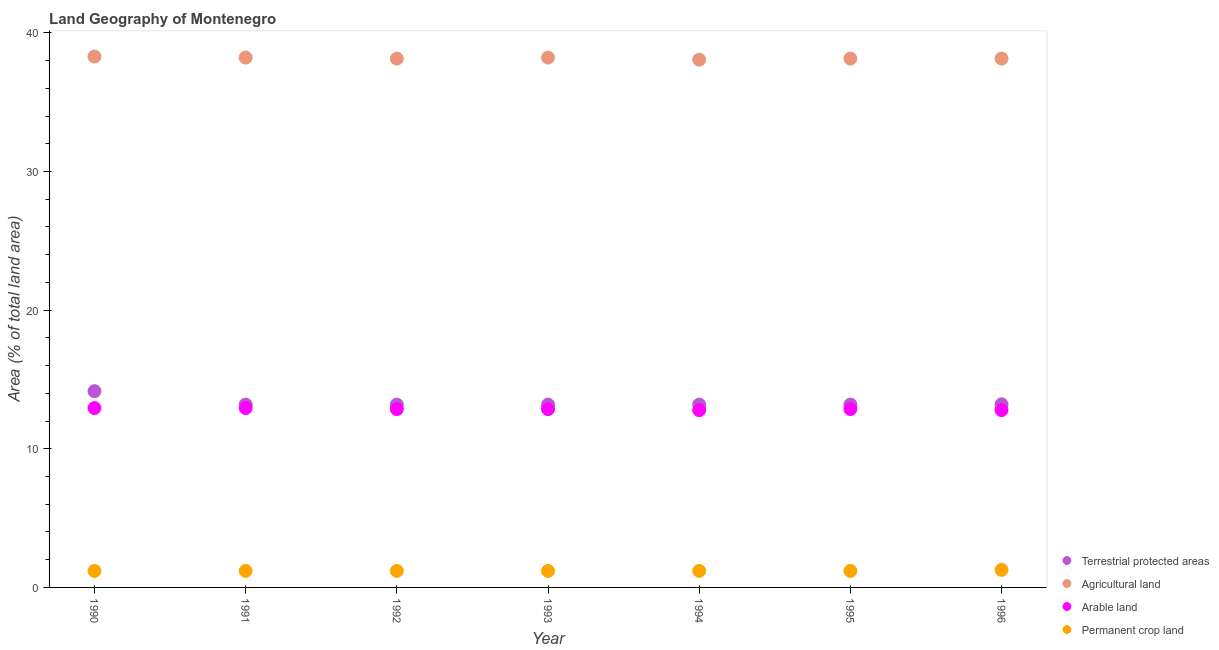Is the number of dotlines equal to the number of legend labels?
Your response must be concise. Yes. What is the percentage of area under agricultural land in 1991?
Offer a terse response. 38.22. Across all years, what is the maximum percentage of area under arable land?
Make the answer very short. 12.94. Across all years, what is the minimum percentage of area under agricultural land?
Your response must be concise. 38.07. In which year was the percentage of area under arable land maximum?
Provide a short and direct response. 1990. In which year was the percentage of area under agricultural land minimum?
Keep it short and to the point. 1994. What is the total percentage of area under permanent crop land in the graph?
Your answer should be very brief. 8.4. What is the difference between the percentage of land under terrestrial protection in 1991 and that in 1992?
Your response must be concise. 0. What is the difference between the percentage of area under agricultural land in 1994 and the percentage of land under terrestrial protection in 1995?
Your response must be concise. 24.88. What is the average percentage of area under agricultural land per year?
Your answer should be compact. 38.17. In the year 1990, what is the difference between the percentage of area under arable land and percentage of land under terrestrial protection?
Your answer should be very brief. -1.22. Is the percentage of area under permanent crop land in 1990 less than that in 1993?
Offer a very short reply. No. What is the difference between the highest and the second highest percentage of area under permanent crop land?
Provide a short and direct response. 0.07. What is the difference between the highest and the lowest percentage of land under terrestrial protection?
Your answer should be compact. 0.97. In how many years, is the percentage of area under agricultural land greater than the average percentage of area under agricultural land taken over all years?
Give a very brief answer. 3. Is the sum of the percentage of area under agricultural land in 1990 and 1994 greater than the maximum percentage of land under terrestrial protection across all years?
Offer a very short reply. Yes. Is it the case that in every year, the sum of the percentage of land under terrestrial protection and percentage of area under agricultural land is greater than the percentage of area under arable land?
Provide a short and direct response. Yes. What is the difference between two consecutive major ticks on the Y-axis?
Offer a very short reply. 10. Does the graph contain any zero values?
Ensure brevity in your answer.  No. Where does the legend appear in the graph?
Your answer should be very brief. Bottom right. How many legend labels are there?
Keep it short and to the point. 4. How are the legend labels stacked?
Offer a terse response. Vertical. What is the title of the graph?
Give a very brief answer. Land Geography of Montenegro. What is the label or title of the Y-axis?
Make the answer very short. Area (% of total land area). What is the Area (% of total land area) of Terrestrial protected areas in 1990?
Make the answer very short. 14.15. What is the Area (% of total land area) in Agricultural land in 1990?
Provide a succinct answer. 38.29. What is the Area (% of total land area) in Arable land in 1990?
Give a very brief answer. 12.94. What is the Area (% of total land area) in Permanent crop land in 1990?
Your answer should be very brief. 1.19. What is the Area (% of total land area) in Terrestrial protected areas in 1991?
Your answer should be very brief. 13.19. What is the Area (% of total land area) of Agricultural land in 1991?
Give a very brief answer. 38.22. What is the Area (% of total land area) in Arable land in 1991?
Your response must be concise. 12.94. What is the Area (% of total land area) of Permanent crop land in 1991?
Give a very brief answer. 1.19. What is the Area (% of total land area) in Terrestrial protected areas in 1992?
Make the answer very short. 13.19. What is the Area (% of total land area) in Agricultural land in 1992?
Provide a succinct answer. 38.14. What is the Area (% of total land area) of Arable land in 1992?
Give a very brief answer. 12.86. What is the Area (% of total land area) in Permanent crop land in 1992?
Your response must be concise. 1.19. What is the Area (% of total land area) in Terrestrial protected areas in 1993?
Offer a very short reply. 13.19. What is the Area (% of total land area) in Agricultural land in 1993?
Make the answer very short. 38.22. What is the Area (% of total land area) in Arable land in 1993?
Ensure brevity in your answer.  12.86. What is the Area (% of total land area) in Permanent crop land in 1993?
Your answer should be compact. 1.19. What is the Area (% of total land area) in Terrestrial protected areas in 1994?
Offer a very short reply. 13.19. What is the Area (% of total land area) of Agricultural land in 1994?
Give a very brief answer. 38.07. What is the Area (% of total land area) in Arable land in 1994?
Your answer should be compact. 12.79. What is the Area (% of total land area) of Permanent crop land in 1994?
Provide a short and direct response. 1.19. What is the Area (% of total land area) of Terrestrial protected areas in 1995?
Ensure brevity in your answer.  13.19. What is the Area (% of total land area) in Agricultural land in 1995?
Provide a succinct answer. 38.14. What is the Area (% of total land area) in Arable land in 1995?
Provide a succinct answer. 12.86. What is the Area (% of total land area) of Permanent crop land in 1995?
Your answer should be very brief. 1.19. What is the Area (% of total land area) of Terrestrial protected areas in 1996?
Keep it short and to the point. 13.21. What is the Area (% of total land area) of Agricultural land in 1996?
Your response must be concise. 38.14. What is the Area (% of total land area) of Arable land in 1996?
Keep it short and to the point. 12.79. What is the Area (% of total land area) of Permanent crop land in 1996?
Keep it short and to the point. 1.26. Across all years, what is the maximum Area (% of total land area) in Terrestrial protected areas?
Offer a very short reply. 14.15. Across all years, what is the maximum Area (% of total land area) of Agricultural land?
Your answer should be very brief. 38.29. Across all years, what is the maximum Area (% of total land area) of Arable land?
Give a very brief answer. 12.94. Across all years, what is the maximum Area (% of total land area) in Permanent crop land?
Make the answer very short. 1.26. Across all years, what is the minimum Area (% of total land area) of Terrestrial protected areas?
Offer a very short reply. 13.19. Across all years, what is the minimum Area (% of total land area) of Agricultural land?
Give a very brief answer. 38.07. Across all years, what is the minimum Area (% of total land area) of Arable land?
Your answer should be very brief. 12.79. Across all years, what is the minimum Area (% of total land area) in Permanent crop land?
Your answer should be very brief. 1.19. What is the total Area (% of total land area) of Terrestrial protected areas in the graph?
Your answer should be very brief. 93.29. What is the total Area (% of total land area) in Agricultural land in the graph?
Ensure brevity in your answer.  267.21. What is the total Area (% of total land area) in Arable land in the graph?
Make the answer very short. 90.04. What is the total Area (% of total land area) in Permanent crop land in the graph?
Your answer should be compact. 8.4. What is the difference between the Area (% of total land area) of Terrestrial protected areas in 1990 and that in 1991?
Give a very brief answer. 0.97. What is the difference between the Area (% of total land area) in Agricultural land in 1990 and that in 1991?
Ensure brevity in your answer.  0.07. What is the difference between the Area (% of total land area) in Arable land in 1990 and that in 1991?
Ensure brevity in your answer.  0. What is the difference between the Area (% of total land area) of Terrestrial protected areas in 1990 and that in 1992?
Keep it short and to the point. 0.97. What is the difference between the Area (% of total land area) of Agricultural land in 1990 and that in 1992?
Offer a very short reply. 0.15. What is the difference between the Area (% of total land area) in Arable land in 1990 and that in 1992?
Ensure brevity in your answer.  0.07. What is the difference between the Area (% of total land area) in Permanent crop land in 1990 and that in 1992?
Keep it short and to the point. 0. What is the difference between the Area (% of total land area) of Terrestrial protected areas in 1990 and that in 1993?
Give a very brief answer. 0.97. What is the difference between the Area (% of total land area) of Agricultural land in 1990 and that in 1993?
Give a very brief answer. 0.07. What is the difference between the Area (% of total land area) in Arable land in 1990 and that in 1993?
Provide a short and direct response. 0.07. What is the difference between the Area (% of total land area) of Permanent crop land in 1990 and that in 1993?
Make the answer very short. 0. What is the difference between the Area (% of total land area) of Terrestrial protected areas in 1990 and that in 1994?
Ensure brevity in your answer.  0.97. What is the difference between the Area (% of total land area) of Agricultural land in 1990 and that in 1994?
Give a very brief answer. 0.22. What is the difference between the Area (% of total land area) of Arable land in 1990 and that in 1994?
Your answer should be very brief. 0.15. What is the difference between the Area (% of total land area) in Agricultural land in 1990 and that in 1995?
Keep it short and to the point. 0.15. What is the difference between the Area (% of total land area) in Arable land in 1990 and that in 1995?
Keep it short and to the point. 0.07. What is the difference between the Area (% of total land area) of Permanent crop land in 1990 and that in 1995?
Keep it short and to the point. 0. What is the difference between the Area (% of total land area) of Terrestrial protected areas in 1990 and that in 1996?
Keep it short and to the point. 0.95. What is the difference between the Area (% of total land area) of Agricultural land in 1990 and that in 1996?
Provide a short and direct response. 0.15. What is the difference between the Area (% of total land area) in Arable land in 1990 and that in 1996?
Your answer should be compact. 0.15. What is the difference between the Area (% of total land area) of Permanent crop land in 1990 and that in 1996?
Offer a terse response. -0.07. What is the difference between the Area (% of total land area) of Agricultural land in 1991 and that in 1992?
Your response must be concise. 0.07. What is the difference between the Area (% of total land area) in Arable land in 1991 and that in 1992?
Your answer should be compact. 0.07. What is the difference between the Area (% of total land area) in Permanent crop land in 1991 and that in 1992?
Your answer should be very brief. 0. What is the difference between the Area (% of total land area) in Agricultural land in 1991 and that in 1993?
Provide a short and direct response. 0. What is the difference between the Area (% of total land area) in Arable land in 1991 and that in 1993?
Your answer should be very brief. 0.07. What is the difference between the Area (% of total land area) in Permanent crop land in 1991 and that in 1993?
Give a very brief answer. 0. What is the difference between the Area (% of total land area) of Agricultural land in 1991 and that in 1994?
Offer a very short reply. 0.15. What is the difference between the Area (% of total land area) in Arable land in 1991 and that in 1994?
Your answer should be very brief. 0.15. What is the difference between the Area (% of total land area) of Permanent crop land in 1991 and that in 1994?
Your answer should be very brief. 0. What is the difference between the Area (% of total land area) in Terrestrial protected areas in 1991 and that in 1995?
Keep it short and to the point. 0. What is the difference between the Area (% of total land area) in Agricultural land in 1991 and that in 1995?
Your response must be concise. 0.07. What is the difference between the Area (% of total land area) in Arable land in 1991 and that in 1995?
Make the answer very short. 0.07. What is the difference between the Area (% of total land area) of Terrestrial protected areas in 1991 and that in 1996?
Keep it short and to the point. -0.02. What is the difference between the Area (% of total land area) in Agricultural land in 1991 and that in 1996?
Ensure brevity in your answer.  0.07. What is the difference between the Area (% of total land area) in Arable land in 1991 and that in 1996?
Your answer should be compact. 0.15. What is the difference between the Area (% of total land area) of Permanent crop land in 1991 and that in 1996?
Your answer should be very brief. -0.07. What is the difference between the Area (% of total land area) in Terrestrial protected areas in 1992 and that in 1993?
Give a very brief answer. 0. What is the difference between the Area (% of total land area) in Agricultural land in 1992 and that in 1993?
Your answer should be compact. -0.07. What is the difference between the Area (% of total land area) in Agricultural land in 1992 and that in 1994?
Ensure brevity in your answer.  0.07. What is the difference between the Area (% of total land area) in Arable land in 1992 and that in 1994?
Offer a terse response. 0.07. What is the difference between the Area (% of total land area) in Terrestrial protected areas in 1992 and that in 1995?
Your answer should be very brief. 0. What is the difference between the Area (% of total land area) of Arable land in 1992 and that in 1995?
Your response must be concise. 0. What is the difference between the Area (% of total land area) in Permanent crop land in 1992 and that in 1995?
Give a very brief answer. 0. What is the difference between the Area (% of total land area) in Terrestrial protected areas in 1992 and that in 1996?
Provide a succinct answer. -0.02. What is the difference between the Area (% of total land area) in Arable land in 1992 and that in 1996?
Make the answer very short. 0.07. What is the difference between the Area (% of total land area) in Permanent crop land in 1992 and that in 1996?
Ensure brevity in your answer.  -0.07. What is the difference between the Area (% of total land area) in Terrestrial protected areas in 1993 and that in 1994?
Ensure brevity in your answer.  0. What is the difference between the Area (% of total land area) in Agricultural land in 1993 and that in 1994?
Provide a short and direct response. 0.15. What is the difference between the Area (% of total land area) in Arable land in 1993 and that in 1994?
Make the answer very short. 0.07. What is the difference between the Area (% of total land area) of Terrestrial protected areas in 1993 and that in 1995?
Give a very brief answer. 0. What is the difference between the Area (% of total land area) in Agricultural land in 1993 and that in 1995?
Make the answer very short. 0.07. What is the difference between the Area (% of total land area) of Terrestrial protected areas in 1993 and that in 1996?
Offer a terse response. -0.02. What is the difference between the Area (% of total land area) in Agricultural land in 1993 and that in 1996?
Offer a very short reply. 0.07. What is the difference between the Area (% of total land area) of Arable land in 1993 and that in 1996?
Give a very brief answer. 0.07. What is the difference between the Area (% of total land area) of Permanent crop land in 1993 and that in 1996?
Make the answer very short. -0.07. What is the difference between the Area (% of total land area) of Terrestrial protected areas in 1994 and that in 1995?
Make the answer very short. 0. What is the difference between the Area (% of total land area) of Agricultural land in 1994 and that in 1995?
Provide a short and direct response. -0.07. What is the difference between the Area (% of total land area) in Arable land in 1994 and that in 1995?
Ensure brevity in your answer.  -0.07. What is the difference between the Area (% of total land area) of Terrestrial protected areas in 1994 and that in 1996?
Provide a succinct answer. -0.02. What is the difference between the Area (% of total land area) of Agricultural land in 1994 and that in 1996?
Provide a succinct answer. -0.07. What is the difference between the Area (% of total land area) of Permanent crop land in 1994 and that in 1996?
Offer a very short reply. -0.07. What is the difference between the Area (% of total land area) in Terrestrial protected areas in 1995 and that in 1996?
Make the answer very short. -0.02. What is the difference between the Area (% of total land area) in Arable land in 1995 and that in 1996?
Ensure brevity in your answer.  0.07. What is the difference between the Area (% of total land area) of Permanent crop land in 1995 and that in 1996?
Offer a very short reply. -0.07. What is the difference between the Area (% of total land area) of Terrestrial protected areas in 1990 and the Area (% of total land area) of Agricultural land in 1991?
Your answer should be very brief. -24.06. What is the difference between the Area (% of total land area) in Terrestrial protected areas in 1990 and the Area (% of total land area) in Arable land in 1991?
Your answer should be very brief. 1.22. What is the difference between the Area (% of total land area) of Terrestrial protected areas in 1990 and the Area (% of total land area) of Permanent crop land in 1991?
Ensure brevity in your answer.  12.97. What is the difference between the Area (% of total land area) in Agricultural land in 1990 and the Area (% of total land area) in Arable land in 1991?
Provide a succinct answer. 25.35. What is the difference between the Area (% of total land area) in Agricultural land in 1990 and the Area (% of total land area) in Permanent crop land in 1991?
Provide a short and direct response. 37.1. What is the difference between the Area (% of total land area) in Arable land in 1990 and the Area (% of total land area) in Permanent crop land in 1991?
Offer a very short reply. 11.75. What is the difference between the Area (% of total land area) in Terrestrial protected areas in 1990 and the Area (% of total land area) in Agricultural land in 1992?
Provide a succinct answer. -23.99. What is the difference between the Area (% of total land area) in Terrestrial protected areas in 1990 and the Area (% of total land area) in Arable land in 1992?
Your answer should be very brief. 1.29. What is the difference between the Area (% of total land area) in Terrestrial protected areas in 1990 and the Area (% of total land area) in Permanent crop land in 1992?
Ensure brevity in your answer.  12.97. What is the difference between the Area (% of total land area) in Agricultural land in 1990 and the Area (% of total land area) in Arable land in 1992?
Offer a terse response. 25.43. What is the difference between the Area (% of total land area) of Agricultural land in 1990 and the Area (% of total land area) of Permanent crop land in 1992?
Your response must be concise. 37.1. What is the difference between the Area (% of total land area) of Arable land in 1990 and the Area (% of total land area) of Permanent crop land in 1992?
Offer a terse response. 11.75. What is the difference between the Area (% of total land area) in Terrestrial protected areas in 1990 and the Area (% of total land area) in Agricultural land in 1993?
Your answer should be compact. -24.06. What is the difference between the Area (% of total land area) in Terrestrial protected areas in 1990 and the Area (% of total land area) in Arable land in 1993?
Your answer should be compact. 1.29. What is the difference between the Area (% of total land area) in Terrestrial protected areas in 1990 and the Area (% of total land area) in Permanent crop land in 1993?
Keep it short and to the point. 12.97. What is the difference between the Area (% of total land area) of Agricultural land in 1990 and the Area (% of total land area) of Arable land in 1993?
Keep it short and to the point. 25.43. What is the difference between the Area (% of total land area) of Agricultural land in 1990 and the Area (% of total land area) of Permanent crop land in 1993?
Provide a succinct answer. 37.1. What is the difference between the Area (% of total land area) in Arable land in 1990 and the Area (% of total land area) in Permanent crop land in 1993?
Offer a terse response. 11.75. What is the difference between the Area (% of total land area) of Terrestrial protected areas in 1990 and the Area (% of total land area) of Agricultural land in 1994?
Your response must be concise. -23.91. What is the difference between the Area (% of total land area) in Terrestrial protected areas in 1990 and the Area (% of total land area) in Arable land in 1994?
Your answer should be compact. 1.37. What is the difference between the Area (% of total land area) of Terrestrial protected areas in 1990 and the Area (% of total land area) of Permanent crop land in 1994?
Offer a terse response. 12.97. What is the difference between the Area (% of total land area) in Agricultural land in 1990 and the Area (% of total land area) in Arable land in 1994?
Your response must be concise. 25.5. What is the difference between the Area (% of total land area) of Agricultural land in 1990 and the Area (% of total land area) of Permanent crop land in 1994?
Ensure brevity in your answer.  37.1. What is the difference between the Area (% of total land area) in Arable land in 1990 and the Area (% of total land area) in Permanent crop land in 1994?
Your answer should be very brief. 11.75. What is the difference between the Area (% of total land area) of Terrestrial protected areas in 1990 and the Area (% of total land area) of Agricultural land in 1995?
Offer a very short reply. -23.99. What is the difference between the Area (% of total land area) of Terrestrial protected areas in 1990 and the Area (% of total land area) of Arable land in 1995?
Make the answer very short. 1.29. What is the difference between the Area (% of total land area) of Terrestrial protected areas in 1990 and the Area (% of total land area) of Permanent crop land in 1995?
Give a very brief answer. 12.97. What is the difference between the Area (% of total land area) in Agricultural land in 1990 and the Area (% of total land area) in Arable land in 1995?
Your response must be concise. 25.43. What is the difference between the Area (% of total land area) of Agricultural land in 1990 and the Area (% of total land area) of Permanent crop land in 1995?
Provide a short and direct response. 37.1. What is the difference between the Area (% of total land area) of Arable land in 1990 and the Area (% of total land area) of Permanent crop land in 1995?
Provide a short and direct response. 11.75. What is the difference between the Area (% of total land area) of Terrestrial protected areas in 1990 and the Area (% of total land area) of Agricultural land in 1996?
Make the answer very short. -23.99. What is the difference between the Area (% of total land area) in Terrestrial protected areas in 1990 and the Area (% of total land area) in Arable land in 1996?
Provide a short and direct response. 1.37. What is the difference between the Area (% of total land area) of Terrestrial protected areas in 1990 and the Area (% of total land area) of Permanent crop land in 1996?
Your response must be concise. 12.89. What is the difference between the Area (% of total land area) of Agricultural land in 1990 and the Area (% of total land area) of Arable land in 1996?
Provide a succinct answer. 25.5. What is the difference between the Area (% of total land area) in Agricultural land in 1990 and the Area (% of total land area) in Permanent crop land in 1996?
Your answer should be very brief. 37.03. What is the difference between the Area (% of total land area) in Arable land in 1990 and the Area (% of total land area) in Permanent crop land in 1996?
Make the answer very short. 11.67. What is the difference between the Area (% of total land area) in Terrestrial protected areas in 1991 and the Area (% of total land area) in Agricultural land in 1992?
Keep it short and to the point. -24.95. What is the difference between the Area (% of total land area) of Terrestrial protected areas in 1991 and the Area (% of total land area) of Arable land in 1992?
Your response must be concise. 0.32. What is the difference between the Area (% of total land area) of Terrestrial protected areas in 1991 and the Area (% of total land area) of Permanent crop land in 1992?
Keep it short and to the point. 12. What is the difference between the Area (% of total land area) of Agricultural land in 1991 and the Area (% of total land area) of Arable land in 1992?
Offer a very short reply. 25.35. What is the difference between the Area (% of total land area) in Agricultural land in 1991 and the Area (% of total land area) in Permanent crop land in 1992?
Provide a succinct answer. 37.03. What is the difference between the Area (% of total land area) in Arable land in 1991 and the Area (% of total land area) in Permanent crop land in 1992?
Keep it short and to the point. 11.75. What is the difference between the Area (% of total land area) in Terrestrial protected areas in 1991 and the Area (% of total land area) in Agricultural land in 1993?
Your response must be concise. -25.03. What is the difference between the Area (% of total land area) in Terrestrial protected areas in 1991 and the Area (% of total land area) in Arable land in 1993?
Offer a very short reply. 0.32. What is the difference between the Area (% of total land area) of Terrestrial protected areas in 1991 and the Area (% of total land area) of Permanent crop land in 1993?
Keep it short and to the point. 12. What is the difference between the Area (% of total land area) in Agricultural land in 1991 and the Area (% of total land area) in Arable land in 1993?
Keep it short and to the point. 25.35. What is the difference between the Area (% of total land area) in Agricultural land in 1991 and the Area (% of total land area) in Permanent crop land in 1993?
Provide a succinct answer. 37.03. What is the difference between the Area (% of total land area) of Arable land in 1991 and the Area (% of total land area) of Permanent crop land in 1993?
Provide a succinct answer. 11.75. What is the difference between the Area (% of total land area) in Terrestrial protected areas in 1991 and the Area (% of total land area) in Agricultural land in 1994?
Ensure brevity in your answer.  -24.88. What is the difference between the Area (% of total land area) of Terrestrial protected areas in 1991 and the Area (% of total land area) of Arable land in 1994?
Ensure brevity in your answer.  0.4. What is the difference between the Area (% of total land area) of Terrestrial protected areas in 1991 and the Area (% of total land area) of Permanent crop land in 1994?
Keep it short and to the point. 12. What is the difference between the Area (% of total land area) of Agricultural land in 1991 and the Area (% of total land area) of Arable land in 1994?
Provide a succinct answer. 25.43. What is the difference between the Area (% of total land area) in Agricultural land in 1991 and the Area (% of total land area) in Permanent crop land in 1994?
Give a very brief answer. 37.03. What is the difference between the Area (% of total land area) of Arable land in 1991 and the Area (% of total land area) of Permanent crop land in 1994?
Offer a very short reply. 11.75. What is the difference between the Area (% of total land area) of Terrestrial protected areas in 1991 and the Area (% of total land area) of Agricultural land in 1995?
Provide a short and direct response. -24.95. What is the difference between the Area (% of total land area) in Terrestrial protected areas in 1991 and the Area (% of total land area) in Arable land in 1995?
Make the answer very short. 0.32. What is the difference between the Area (% of total land area) in Terrestrial protected areas in 1991 and the Area (% of total land area) in Permanent crop land in 1995?
Offer a very short reply. 12. What is the difference between the Area (% of total land area) in Agricultural land in 1991 and the Area (% of total land area) in Arable land in 1995?
Give a very brief answer. 25.35. What is the difference between the Area (% of total land area) in Agricultural land in 1991 and the Area (% of total land area) in Permanent crop land in 1995?
Your response must be concise. 37.03. What is the difference between the Area (% of total land area) of Arable land in 1991 and the Area (% of total land area) of Permanent crop land in 1995?
Provide a succinct answer. 11.75. What is the difference between the Area (% of total land area) of Terrestrial protected areas in 1991 and the Area (% of total land area) of Agricultural land in 1996?
Offer a very short reply. -24.95. What is the difference between the Area (% of total land area) in Terrestrial protected areas in 1991 and the Area (% of total land area) in Arable land in 1996?
Your answer should be compact. 0.4. What is the difference between the Area (% of total land area) in Terrestrial protected areas in 1991 and the Area (% of total land area) in Permanent crop land in 1996?
Your answer should be compact. 11.92. What is the difference between the Area (% of total land area) of Agricultural land in 1991 and the Area (% of total land area) of Arable land in 1996?
Offer a terse response. 25.43. What is the difference between the Area (% of total land area) of Agricultural land in 1991 and the Area (% of total land area) of Permanent crop land in 1996?
Give a very brief answer. 36.95. What is the difference between the Area (% of total land area) of Arable land in 1991 and the Area (% of total land area) of Permanent crop land in 1996?
Your response must be concise. 11.67. What is the difference between the Area (% of total land area) in Terrestrial protected areas in 1992 and the Area (% of total land area) in Agricultural land in 1993?
Keep it short and to the point. -25.03. What is the difference between the Area (% of total land area) of Terrestrial protected areas in 1992 and the Area (% of total land area) of Arable land in 1993?
Provide a short and direct response. 0.32. What is the difference between the Area (% of total land area) of Terrestrial protected areas in 1992 and the Area (% of total land area) of Permanent crop land in 1993?
Give a very brief answer. 12. What is the difference between the Area (% of total land area) in Agricultural land in 1992 and the Area (% of total land area) in Arable land in 1993?
Give a very brief answer. 25.28. What is the difference between the Area (% of total land area) of Agricultural land in 1992 and the Area (% of total land area) of Permanent crop land in 1993?
Provide a succinct answer. 36.95. What is the difference between the Area (% of total land area) of Arable land in 1992 and the Area (% of total land area) of Permanent crop land in 1993?
Your answer should be compact. 11.67. What is the difference between the Area (% of total land area) of Terrestrial protected areas in 1992 and the Area (% of total land area) of Agricultural land in 1994?
Give a very brief answer. -24.88. What is the difference between the Area (% of total land area) of Terrestrial protected areas in 1992 and the Area (% of total land area) of Arable land in 1994?
Ensure brevity in your answer.  0.4. What is the difference between the Area (% of total land area) of Terrestrial protected areas in 1992 and the Area (% of total land area) of Permanent crop land in 1994?
Your answer should be very brief. 12. What is the difference between the Area (% of total land area) in Agricultural land in 1992 and the Area (% of total land area) in Arable land in 1994?
Give a very brief answer. 25.35. What is the difference between the Area (% of total land area) in Agricultural land in 1992 and the Area (% of total land area) in Permanent crop land in 1994?
Make the answer very short. 36.95. What is the difference between the Area (% of total land area) in Arable land in 1992 and the Area (% of total land area) in Permanent crop land in 1994?
Your answer should be compact. 11.67. What is the difference between the Area (% of total land area) of Terrestrial protected areas in 1992 and the Area (% of total land area) of Agricultural land in 1995?
Provide a short and direct response. -24.95. What is the difference between the Area (% of total land area) in Terrestrial protected areas in 1992 and the Area (% of total land area) in Arable land in 1995?
Provide a short and direct response. 0.32. What is the difference between the Area (% of total land area) in Terrestrial protected areas in 1992 and the Area (% of total land area) in Permanent crop land in 1995?
Make the answer very short. 12. What is the difference between the Area (% of total land area) of Agricultural land in 1992 and the Area (% of total land area) of Arable land in 1995?
Offer a terse response. 25.28. What is the difference between the Area (% of total land area) in Agricultural land in 1992 and the Area (% of total land area) in Permanent crop land in 1995?
Make the answer very short. 36.95. What is the difference between the Area (% of total land area) of Arable land in 1992 and the Area (% of total land area) of Permanent crop land in 1995?
Keep it short and to the point. 11.67. What is the difference between the Area (% of total land area) of Terrestrial protected areas in 1992 and the Area (% of total land area) of Agricultural land in 1996?
Give a very brief answer. -24.95. What is the difference between the Area (% of total land area) of Terrestrial protected areas in 1992 and the Area (% of total land area) of Arable land in 1996?
Provide a succinct answer. 0.4. What is the difference between the Area (% of total land area) of Terrestrial protected areas in 1992 and the Area (% of total land area) of Permanent crop land in 1996?
Provide a succinct answer. 11.92. What is the difference between the Area (% of total land area) in Agricultural land in 1992 and the Area (% of total land area) in Arable land in 1996?
Keep it short and to the point. 25.35. What is the difference between the Area (% of total land area) in Agricultural land in 1992 and the Area (% of total land area) in Permanent crop land in 1996?
Keep it short and to the point. 36.88. What is the difference between the Area (% of total land area) in Arable land in 1992 and the Area (% of total land area) in Permanent crop land in 1996?
Make the answer very short. 11.6. What is the difference between the Area (% of total land area) in Terrestrial protected areas in 1993 and the Area (% of total land area) in Agricultural land in 1994?
Give a very brief answer. -24.88. What is the difference between the Area (% of total land area) in Terrestrial protected areas in 1993 and the Area (% of total land area) in Arable land in 1994?
Your response must be concise. 0.4. What is the difference between the Area (% of total land area) of Terrestrial protected areas in 1993 and the Area (% of total land area) of Permanent crop land in 1994?
Ensure brevity in your answer.  12. What is the difference between the Area (% of total land area) in Agricultural land in 1993 and the Area (% of total land area) in Arable land in 1994?
Provide a short and direct response. 25.43. What is the difference between the Area (% of total land area) of Agricultural land in 1993 and the Area (% of total land area) of Permanent crop land in 1994?
Provide a succinct answer. 37.03. What is the difference between the Area (% of total land area) in Arable land in 1993 and the Area (% of total land area) in Permanent crop land in 1994?
Keep it short and to the point. 11.67. What is the difference between the Area (% of total land area) of Terrestrial protected areas in 1993 and the Area (% of total land area) of Agricultural land in 1995?
Keep it short and to the point. -24.95. What is the difference between the Area (% of total land area) in Terrestrial protected areas in 1993 and the Area (% of total land area) in Arable land in 1995?
Ensure brevity in your answer.  0.32. What is the difference between the Area (% of total land area) in Terrestrial protected areas in 1993 and the Area (% of total land area) in Permanent crop land in 1995?
Ensure brevity in your answer.  12. What is the difference between the Area (% of total land area) in Agricultural land in 1993 and the Area (% of total land area) in Arable land in 1995?
Provide a short and direct response. 25.35. What is the difference between the Area (% of total land area) in Agricultural land in 1993 and the Area (% of total land area) in Permanent crop land in 1995?
Keep it short and to the point. 37.03. What is the difference between the Area (% of total land area) of Arable land in 1993 and the Area (% of total land area) of Permanent crop land in 1995?
Your answer should be very brief. 11.67. What is the difference between the Area (% of total land area) in Terrestrial protected areas in 1993 and the Area (% of total land area) in Agricultural land in 1996?
Your response must be concise. -24.95. What is the difference between the Area (% of total land area) of Terrestrial protected areas in 1993 and the Area (% of total land area) of Arable land in 1996?
Provide a short and direct response. 0.4. What is the difference between the Area (% of total land area) in Terrestrial protected areas in 1993 and the Area (% of total land area) in Permanent crop land in 1996?
Ensure brevity in your answer.  11.92. What is the difference between the Area (% of total land area) in Agricultural land in 1993 and the Area (% of total land area) in Arable land in 1996?
Your response must be concise. 25.43. What is the difference between the Area (% of total land area) in Agricultural land in 1993 and the Area (% of total land area) in Permanent crop land in 1996?
Your response must be concise. 36.95. What is the difference between the Area (% of total land area) of Arable land in 1993 and the Area (% of total land area) of Permanent crop land in 1996?
Offer a very short reply. 11.6. What is the difference between the Area (% of total land area) in Terrestrial protected areas in 1994 and the Area (% of total land area) in Agricultural land in 1995?
Your answer should be compact. -24.95. What is the difference between the Area (% of total land area) in Terrestrial protected areas in 1994 and the Area (% of total land area) in Arable land in 1995?
Provide a short and direct response. 0.32. What is the difference between the Area (% of total land area) of Terrestrial protected areas in 1994 and the Area (% of total land area) of Permanent crop land in 1995?
Keep it short and to the point. 12. What is the difference between the Area (% of total land area) of Agricultural land in 1994 and the Area (% of total land area) of Arable land in 1995?
Your answer should be very brief. 25.2. What is the difference between the Area (% of total land area) of Agricultural land in 1994 and the Area (% of total land area) of Permanent crop land in 1995?
Your response must be concise. 36.88. What is the difference between the Area (% of total land area) of Arable land in 1994 and the Area (% of total land area) of Permanent crop land in 1995?
Your response must be concise. 11.6. What is the difference between the Area (% of total land area) in Terrestrial protected areas in 1994 and the Area (% of total land area) in Agricultural land in 1996?
Provide a succinct answer. -24.95. What is the difference between the Area (% of total land area) in Terrestrial protected areas in 1994 and the Area (% of total land area) in Arable land in 1996?
Provide a succinct answer. 0.4. What is the difference between the Area (% of total land area) in Terrestrial protected areas in 1994 and the Area (% of total land area) in Permanent crop land in 1996?
Ensure brevity in your answer.  11.92. What is the difference between the Area (% of total land area) of Agricultural land in 1994 and the Area (% of total land area) of Arable land in 1996?
Your answer should be very brief. 25.28. What is the difference between the Area (% of total land area) in Agricultural land in 1994 and the Area (% of total land area) in Permanent crop land in 1996?
Keep it short and to the point. 36.8. What is the difference between the Area (% of total land area) in Arable land in 1994 and the Area (% of total land area) in Permanent crop land in 1996?
Offer a very short reply. 11.52. What is the difference between the Area (% of total land area) in Terrestrial protected areas in 1995 and the Area (% of total land area) in Agricultural land in 1996?
Your response must be concise. -24.95. What is the difference between the Area (% of total land area) in Terrestrial protected areas in 1995 and the Area (% of total land area) in Arable land in 1996?
Keep it short and to the point. 0.4. What is the difference between the Area (% of total land area) of Terrestrial protected areas in 1995 and the Area (% of total land area) of Permanent crop land in 1996?
Ensure brevity in your answer.  11.92. What is the difference between the Area (% of total land area) in Agricultural land in 1995 and the Area (% of total land area) in Arable land in 1996?
Provide a short and direct response. 25.35. What is the difference between the Area (% of total land area) of Agricultural land in 1995 and the Area (% of total land area) of Permanent crop land in 1996?
Offer a terse response. 36.88. What is the difference between the Area (% of total land area) of Arable land in 1995 and the Area (% of total land area) of Permanent crop land in 1996?
Your response must be concise. 11.6. What is the average Area (% of total land area) of Terrestrial protected areas per year?
Your answer should be very brief. 13.33. What is the average Area (% of total land area) of Agricultural land per year?
Ensure brevity in your answer.  38.17. What is the average Area (% of total land area) in Arable land per year?
Make the answer very short. 12.86. What is the average Area (% of total land area) in Permanent crop land per year?
Your response must be concise. 1.2. In the year 1990, what is the difference between the Area (% of total land area) of Terrestrial protected areas and Area (% of total land area) of Agricultural land?
Your answer should be compact. -24.14. In the year 1990, what is the difference between the Area (% of total land area) in Terrestrial protected areas and Area (% of total land area) in Arable land?
Your answer should be compact. 1.22. In the year 1990, what is the difference between the Area (% of total land area) in Terrestrial protected areas and Area (% of total land area) in Permanent crop land?
Provide a succinct answer. 12.97. In the year 1990, what is the difference between the Area (% of total land area) of Agricultural land and Area (% of total land area) of Arable land?
Make the answer very short. 25.35. In the year 1990, what is the difference between the Area (% of total land area) of Agricultural land and Area (% of total land area) of Permanent crop land?
Make the answer very short. 37.1. In the year 1990, what is the difference between the Area (% of total land area) in Arable land and Area (% of total land area) in Permanent crop land?
Provide a succinct answer. 11.75. In the year 1991, what is the difference between the Area (% of total land area) of Terrestrial protected areas and Area (% of total land area) of Agricultural land?
Keep it short and to the point. -25.03. In the year 1991, what is the difference between the Area (% of total land area) in Terrestrial protected areas and Area (% of total land area) in Arable land?
Offer a very short reply. 0.25. In the year 1991, what is the difference between the Area (% of total land area) in Terrestrial protected areas and Area (% of total land area) in Permanent crop land?
Offer a very short reply. 12. In the year 1991, what is the difference between the Area (% of total land area) of Agricultural land and Area (% of total land area) of Arable land?
Ensure brevity in your answer.  25.28. In the year 1991, what is the difference between the Area (% of total land area) of Agricultural land and Area (% of total land area) of Permanent crop land?
Ensure brevity in your answer.  37.03. In the year 1991, what is the difference between the Area (% of total land area) of Arable land and Area (% of total land area) of Permanent crop land?
Your answer should be compact. 11.75. In the year 1992, what is the difference between the Area (% of total land area) in Terrestrial protected areas and Area (% of total land area) in Agricultural land?
Your response must be concise. -24.95. In the year 1992, what is the difference between the Area (% of total land area) in Terrestrial protected areas and Area (% of total land area) in Arable land?
Keep it short and to the point. 0.32. In the year 1992, what is the difference between the Area (% of total land area) of Terrestrial protected areas and Area (% of total land area) of Permanent crop land?
Keep it short and to the point. 12. In the year 1992, what is the difference between the Area (% of total land area) in Agricultural land and Area (% of total land area) in Arable land?
Offer a very short reply. 25.28. In the year 1992, what is the difference between the Area (% of total land area) of Agricultural land and Area (% of total land area) of Permanent crop land?
Give a very brief answer. 36.95. In the year 1992, what is the difference between the Area (% of total land area) of Arable land and Area (% of total land area) of Permanent crop land?
Offer a terse response. 11.67. In the year 1993, what is the difference between the Area (% of total land area) of Terrestrial protected areas and Area (% of total land area) of Agricultural land?
Keep it short and to the point. -25.03. In the year 1993, what is the difference between the Area (% of total land area) in Terrestrial protected areas and Area (% of total land area) in Arable land?
Give a very brief answer. 0.32. In the year 1993, what is the difference between the Area (% of total land area) in Terrestrial protected areas and Area (% of total land area) in Permanent crop land?
Ensure brevity in your answer.  12. In the year 1993, what is the difference between the Area (% of total land area) of Agricultural land and Area (% of total land area) of Arable land?
Your response must be concise. 25.35. In the year 1993, what is the difference between the Area (% of total land area) of Agricultural land and Area (% of total land area) of Permanent crop land?
Give a very brief answer. 37.03. In the year 1993, what is the difference between the Area (% of total land area) in Arable land and Area (% of total land area) in Permanent crop land?
Provide a short and direct response. 11.67. In the year 1994, what is the difference between the Area (% of total land area) in Terrestrial protected areas and Area (% of total land area) in Agricultural land?
Make the answer very short. -24.88. In the year 1994, what is the difference between the Area (% of total land area) of Terrestrial protected areas and Area (% of total land area) of Arable land?
Offer a very short reply. 0.4. In the year 1994, what is the difference between the Area (% of total land area) of Terrestrial protected areas and Area (% of total land area) of Permanent crop land?
Ensure brevity in your answer.  12. In the year 1994, what is the difference between the Area (% of total land area) in Agricultural land and Area (% of total land area) in Arable land?
Provide a short and direct response. 25.28. In the year 1994, what is the difference between the Area (% of total land area) of Agricultural land and Area (% of total land area) of Permanent crop land?
Your response must be concise. 36.88. In the year 1994, what is the difference between the Area (% of total land area) of Arable land and Area (% of total land area) of Permanent crop land?
Make the answer very short. 11.6. In the year 1995, what is the difference between the Area (% of total land area) of Terrestrial protected areas and Area (% of total land area) of Agricultural land?
Offer a very short reply. -24.95. In the year 1995, what is the difference between the Area (% of total land area) in Terrestrial protected areas and Area (% of total land area) in Arable land?
Make the answer very short. 0.32. In the year 1995, what is the difference between the Area (% of total land area) of Terrestrial protected areas and Area (% of total land area) of Permanent crop land?
Provide a succinct answer. 12. In the year 1995, what is the difference between the Area (% of total land area) in Agricultural land and Area (% of total land area) in Arable land?
Provide a succinct answer. 25.28. In the year 1995, what is the difference between the Area (% of total land area) in Agricultural land and Area (% of total land area) in Permanent crop land?
Your answer should be very brief. 36.95. In the year 1995, what is the difference between the Area (% of total land area) in Arable land and Area (% of total land area) in Permanent crop land?
Provide a short and direct response. 11.67. In the year 1996, what is the difference between the Area (% of total land area) of Terrestrial protected areas and Area (% of total land area) of Agricultural land?
Make the answer very short. -24.94. In the year 1996, what is the difference between the Area (% of total land area) of Terrestrial protected areas and Area (% of total land area) of Arable land?
Your answer should be compact. 0.42. In the year 1996, what is the difference between the Area (% of total land area) in Terrestrial protected areas and Area (% of total land area) in Permanent crop land?
Your answer should be compact. 11.94. In the year 1996, what is the difference between the Area (% of total land area) in Agricultural land and Area (% of total land area) in Arable land?
Your answer should be very brief. 25.35. In the year 1996, what is the difference between the Area (% of total land area) of Agricultural land and Area (% of total land area) of Permanent crop land?
Provide a short and direct response. 36.88. In the year 1996, what is the difference between the Area (% of total land area) in Arable land and Area (% of total land area) in Permanent crop land?
Offer a very short reply. 11.52. What is the ratio of the Area (% of total land area) in Terrestrial protected areas in 1990 to that in 1991?
Make the answer very short. 1.07. What is the ratio of the Area (% of total land area) in Agricultural land in 1990 to that in 1991?
Offer a terse response. 1. What is the ratio of the Area (% of total land area) of Terrestrial protected areas in 1990 to that in 1992?
Provide a short and direct response. 1.07. What is the ratio of the Area (% of total land area) in Terrestrial protected areas in 1990 to that in 1993?
Provide a short and direct response. 1.07. What is the ratio of the Area (% of total land area) in Permanent crop land in 1990 to that in 1993?
Provide a succinct answer. 1. What is the ratio of the Area (% of total land area) in Terrestrial protected areas in 1990 to that in 1994?
Give a very brief answer. 1.07. What is the ratio of the Area (% of total land area) of Agricultural land in 1990 to that in 1994?
Ensure brevity in your answer.  1.01. What is the ratio of the Area (% of total land area) of Arable land in 1990 to that in 1994?
Your answer should be very brief. 1.01. What is the ratio of the Area (% of total land area) of Terrestrial protected areas in 1990 to that in 1995?
Make the answer very short. 1.07. What is the ratio of the Area (% of total land area) in Permanent crop land in 1990 to that in 1995?
Your response must be concise. 1. What is the ratio of the Area (% of total land area) in Terrestrial protected areas in 1990 to that in 1996?
Your answer should be compact. 1.07. What is the ratio of the Area (% of total land area) of Arable land in 1990 to that in 1996?
Make the answer very short. 1.01. What is the ratio of the Area (% of total land area) of Permanent crop land in 1990 to that in 1996?
Your response must be concise. 0.94. What is the ratio of the Area (% of total land area) of Agricultural land in 1991 to that in 1992?
Keep it short and to the point. 1. What is the ratio of the Area (% of total land area) of Permanent crop land in 1991 to that in 1992?
Offer a terse response. 1. What is the ratio of the Area (% of total land area) of Agricultural land in 1991 to that in 1993?
Make the answer very short. 1. What is the ratio of the Area (% of total land area) of Arable land in 1991 to that in 1994?
Ensure brevity in your answer.  1.01. What is the ratio of the Area (% of total land area) in Permanent crop land in 1991 to that in 1994?
Offer a terse response. 1. What is the ratio of the Area (% of total land area) of Agricultural land in 1991 to that in 1995?
Keep it short and to the point. 1. What is the ratio of the Area (% of total land area) of Arable land in 1991 to that in 1996?
Offer a terse response. 1.01. What is the ratio of the Area (% of total land area) in Agricultural land in 1992 to that in 1993?
Offer a very short reply. 1. What is the ratio of the Area (% of total land area) of Terrestrial protected areas in 1992 to that in 1994?
Your answer should be compact. 1. What is the ratio of the Area (% of total land area) in Agricultural land in 1992 to that in 1994?
Your answer should be compact. 1. What is the ratio of the Area (% of total land area) of Arable land in 1992 to that in 1995?
Offer a terse response. 1. What is the ratio of the Area (% of total land area) of Agricultural land in 1992 to that in 1996?
Provide a succinct answer. 1. What is the ratio of the Area (% of total land area) in Arable land in 1993 to that in 1994?
Keep it short and to the point. 1.01. What is the ratio of the Area (% of total land area) in Terrestrial protected areas in 1993 to that in 1995?
Your response must be concise. 1. What is the ratio of the Area (% of total land area) of Permanent crop land in 1993 to that in 1995?
Your response must be concise. 1. What is the ratio of the Area (% of total land area) of Terrestrial protected areas in 1993 to that in 1996?
Make the answer very short. 1. What is the ratio of the Area (% of total land area) in Permanent crop land in 1993 to that in 1996?
Keep it short and to the point. 0.94. What is the ratio of the Area (% of total land area) of Terrestrial protected areas in 1994 to that in 1995?
Your answer should be very brief. 1. What is the ratio of the Area (% of total land area) in Agricultural land in 1994 to that in 1995?
Provide a short and direct response. 1. What is the ratio of the Area (% of total land area) in Terrestrial protected areas in 1994 to that in 1996?
Your response must be concise. 1. What is the ratio of the Area (% of total land area) in Agricultural land in 1994 to that in 1996?
Keep it short and to the point. 1. What is the ratio of the Area (% of total land area) of Arable land in 1994 to that in 1996?
Offer a terse response. 1. What is the ratio of the Area (% of total land area) in Permanent crop land in 1995 to that in 1996?
Offer a very short reply. 0.94. What is the difference between the highest and the second highest Area (% of total land area) in Terrestrial protected areas?
Give a very brief answer. 0.95. What is the difference between the highest and the second highest Area (% of total land area) in Agricultural land?
Your response must be concise. 0.07. What is the difference between the highest and the second highest Area (% of total land area) in Permanent crop land?
Provide a short and direct response. 0.07. What is the difference between the highest and the lowest Area (% of total land area) of Agricultural land?
Your answer should be very brief. 0.22. What is the difference between the highest and the lowest Area (% of total land area) of Arable land?
Your response must be concise. 0.15. What is the difference between the highest and the lowest Area (% of total land area) of Permanent crop land?
Your answer should be compact. 0.07. 